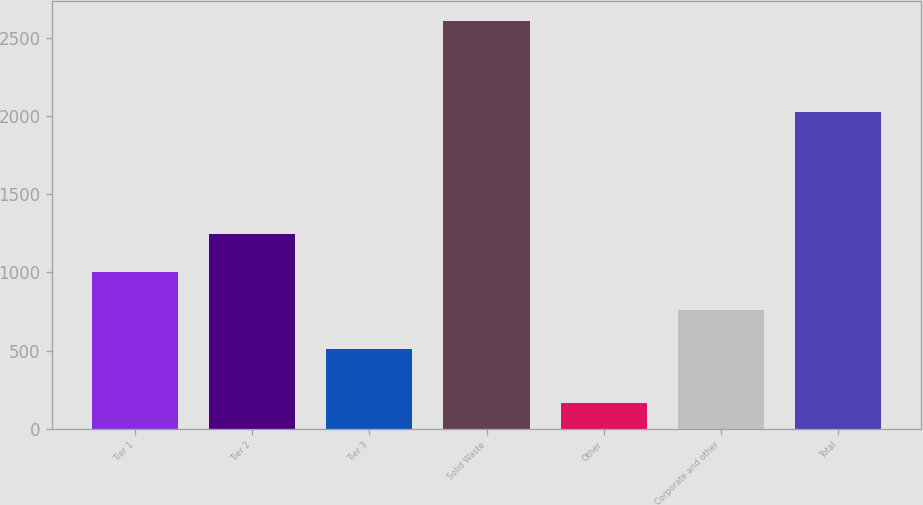Convert chart to OTSL. <chart><loc_0><loc_0><loc_500><loc_500><bar_chart><fcel>Tier 1<fcel>Tier 2<fcel>Tier 3<fcel>Solid Waste<fcel>Other<fcel>Corporate and other<fcel>Total<nl><fcel>1000.8<fcel>1245.2<fcel>512<fcel>2608<fcel>164<fcel>756.4<fcel>2028<nl></chart> 